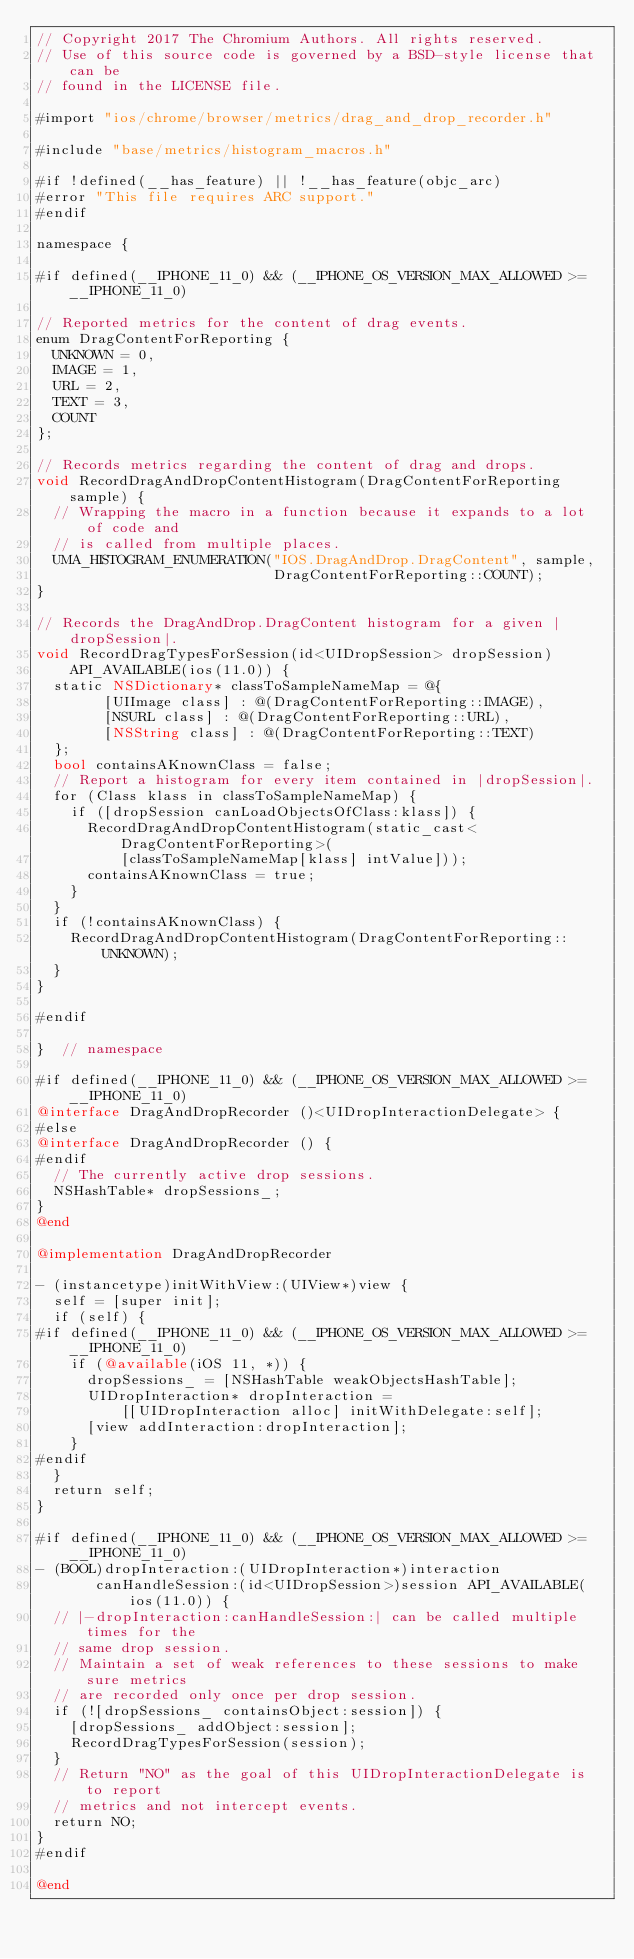Convert code to text. <code><loc_0><loc_0><loc_500><loc_500><_ObjectiveC_>// Copyright 2017 The Chromium Authors. All rights reserved.
// Use of this source code is governed by a BSD-style license that can be
// found in the LICENSE file.

#import "ios/chrome/browser/metrics/drag_and_drop_recorder.h"

#include "base/metrics/histogram_macros.h"

#if !defined(__has_feature) || !__has_feature(objc_arc)
#error "This file requires ARC support."
#endif

namespace {

#if defined(__IPHONE_11_0) && (__IPHONE_OS_VERSION_MAX_ALLOWED >= __IPHONE_11_0)

// Reported metrics for the content of drag events.
enum DragContentForReporting {
  UNKNOWN = 0,
  IMAGE = 1,
  URL = 2,
  TEXT = 3,
  COUNT
};

// Records metrics regarding the content of drag and drops.
void RecordDragAndDropContentHistogram(DragContentForReporting sample) {
  // Wrapping the macro in a function because it expands to a lot of code and
  // is called from multiple places.
  UMA_HISTOGRAM_ENUMERATION("IOS.DragAndDrop.DragContent", sample,
                            DragContentForReporting::COUNT);
}

// Records the DragAndDrop.DragContent histogram for a given |dropSession|.
void RecordDragTypesForSession(id<UIDropSession> dropSession)
    API_AVAILABLE(ios(11.0)) {
  static NSDictionary* classToSampleNameMap = @{
        [UIImage class] : @(DragContentForReporting::IMAGE),
        [NSURL class] : @(DragContentForReporting::URL),
        [NSString class] : @(DragContentForReporting::TEXT)
  };
  bool containsAKnownClass = false;
  // Report a histogram for every item contained in |dropSession|.
  for (Class klass in classToSampleNameMap) {
    if ([dropSession canLoadObjectsOfClass:klass]) {
      RecordDragAndDropContentHistogram(static_cast<DragContentForReporting>(
          [classToSampleNameMap[klass] intValue]));
      containsAKnownClass = true;
    }
  }
  if (!containsAKnownClass) {
    RecordDragAndDropContentHistogram(DragContentForReporting::UNKNOWN);
  }
}

#endif

}  // namespace

#if defined(__IPHONE_11_0) && (__IPHONE_OS_VERSION_MAX_ALLOWED >= __IPHONE_11_0)
@interface DragAndDropRecorder ()<UIDropInteractionDelegate> {
#else
@interface DragAndDropRecorder () {
#endif
  // The currently active drop sessions.
  NSHashTable* dropSessions_;
}
@end

@implementation DragAndDropRecorder

- (instancetype)initWithView:(UIView*)view {
  self = [super init];
  if (self) {
#if defined(__IPHONE_11_0) && (__IPHONE_OS_VERSION_MAX_ALLOWED >= __IPHONE_11_0)
    if (@available(iOS 11, *)) {
      dropSessions_ = [NSHashTable weakObjectsHashTable];
      UIDropInteraction* dropInteraction =
          [[UIDropInteraction alloc] initWithDelegate:self];
      [view addInteraction:dropInteraction];
    }
#endif
  }
  return self;
}

#if defined(__IPHONE_11_0) && (__IPHONE_OS_VERSION_MAX_ALLOWED >= __IPHONE_11_0)
- (BOOL)dropInteraction:(UIDropInteraction*)interaction
       canHandleSession:(id<UIDropSession>)session API_AVAILABLE(ios(11.0)) {
  // |-dropInteraction:canHandleSession:| can be called multiple times for the
  // same drop session.
  // Maintain a set of weak references to these sessions to make sure metrics
  // are recorded only once per drop session.
  if (![dropSessions_ containsObject:session]) {
    [dropSessions_ addObject:session];
    RecordDragTypesForSession(session);
  }
  // Return "NO" as the goal of this UIDropInteractionDelegate is to report
  // metrics and not intercept events.
  return NO;
}
#endif

@end
</code> 